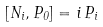Convert formula to latex. <formula><loc_0><loc_0><loc_500><loc_500>\left [ N _ { i } , P _ { 0 } \right ] = i \, P _ { i }</formula> 